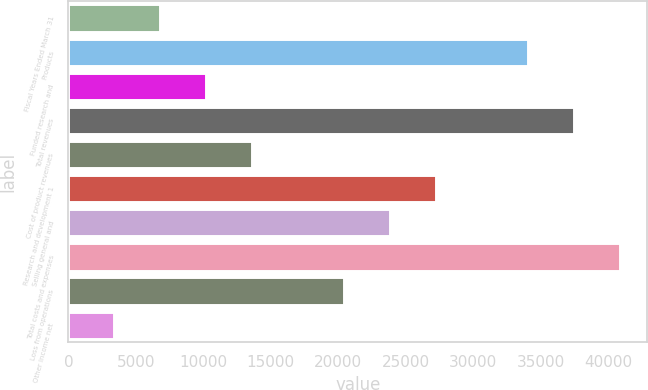Convert chart to OTSL. <chart><loc_0><loc_0><loc_500><loc_500><bar_chart><fcel>Fiscal Years Ended March 31<fcel>Products<fcel>Funded research and<fcel>Total revenues<fcel>Cost of product revenues<fcel>Research and development 1<fcel>Selling general and<fcel>Total costs and expenses<fcel>Loss from operations<fcel>Other income net<nl><fcel>6813.44<fcel>34065<fcel>10219.9<fcel>37471.4<fcel>13626.3<fcel>27252.1<fcel>23845.6<fcel>40877.8<fcel>20439.2<fcel>3407<nl></chart> 